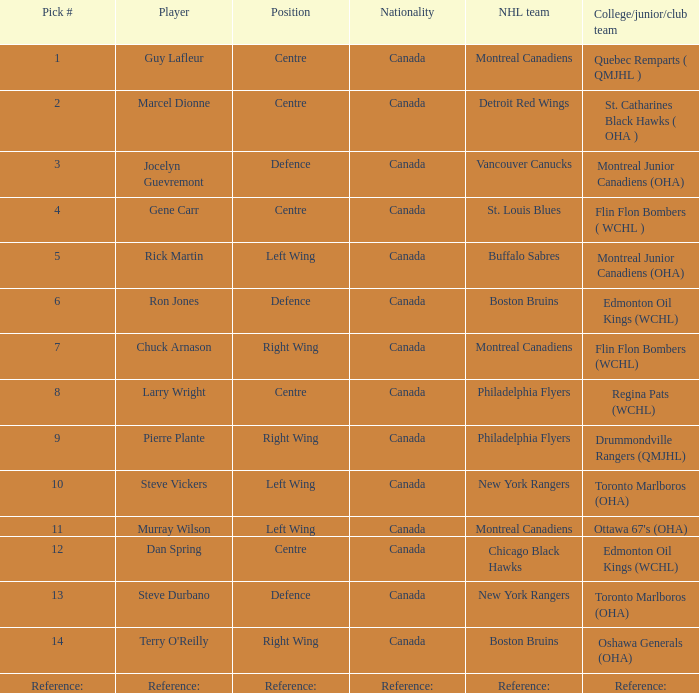Which college/junior/club team possesses a pick # of 1? Quebec Remparts ( QMJHL ). 